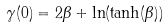Convert formula to latex. <formula><loc_0><loc_0><loc_500><loc_500>\gamma ( 0 ) = 2 \beta + \ln ( \tanh ( \beta ) )</formula> 